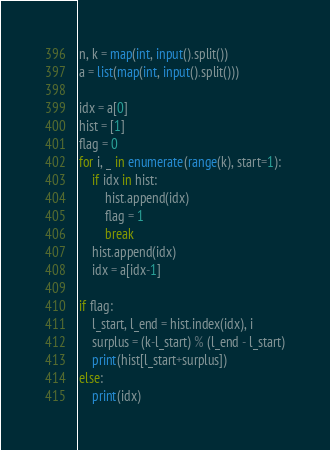Convert code to text. <code><loc_0><loc_0><loc_500><loc_500><_Python_>n, k = map(int, input().split())
a = list(map(int, input().split()))

idx = a[0]
hist = [1]
flag = 0
for i, _ in enumerate(range(k), start=1):
    if idx in hist:
        hist.append(idx)
        flag = 1
        break
    hist.append(idx)
    idx = a[idx-1]
    
if flag:
    l_start, l_end = hist.index(idx), i
    surplus = (k-l_start) % (l_end - l_start)
    print(hist[l_start+surplus])
else:
    print(idx)</code> 